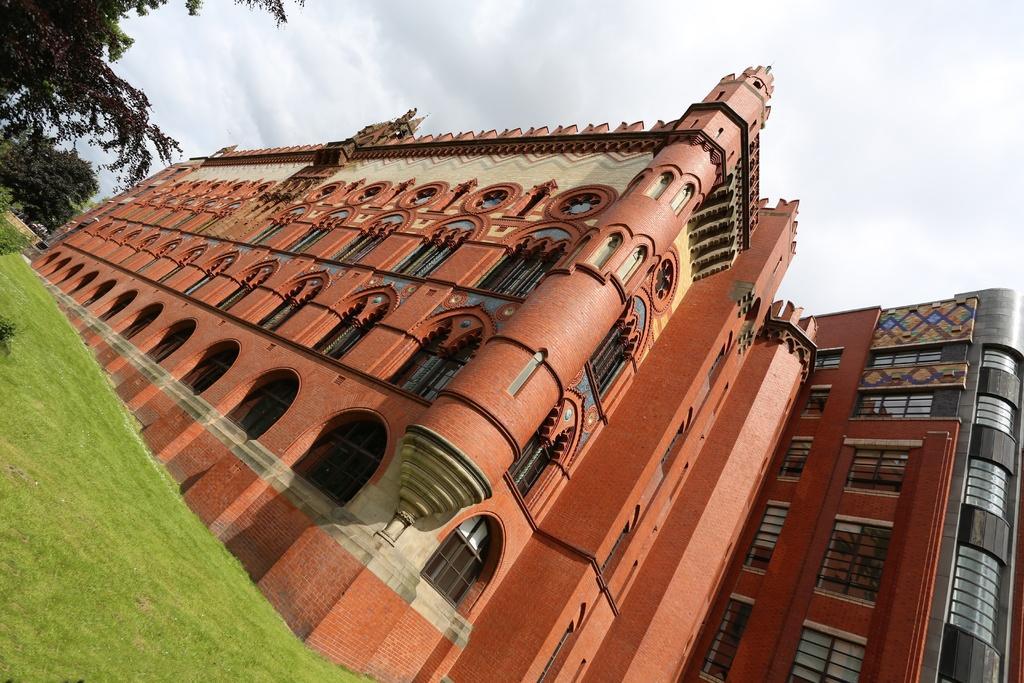Describe this image in one or two sentences. In this picture there is a building. On the building we can see many windows and glass. At the bottom left corner we can see grass. in the background we can see many trees. At the top we can see sky and clouds. 